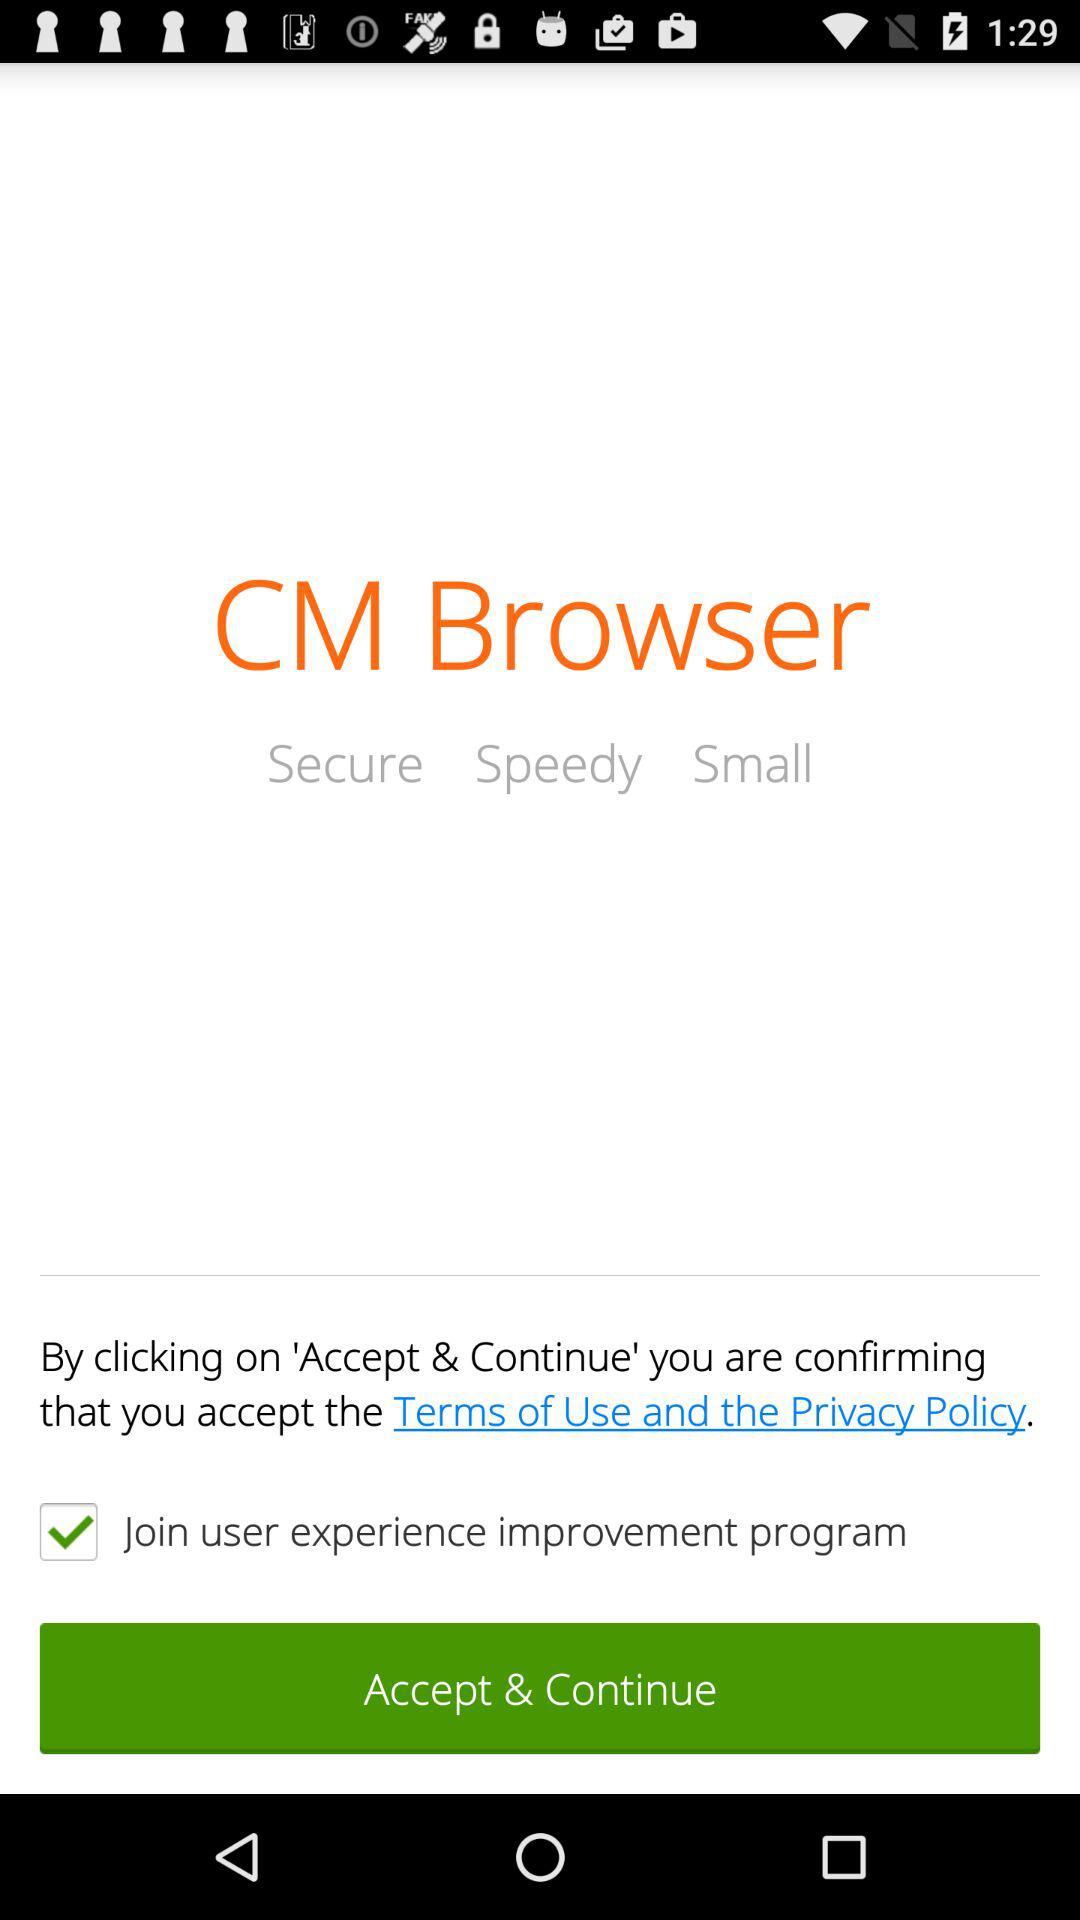What's the selected option? The selected option is "Join user experience improvement program". 